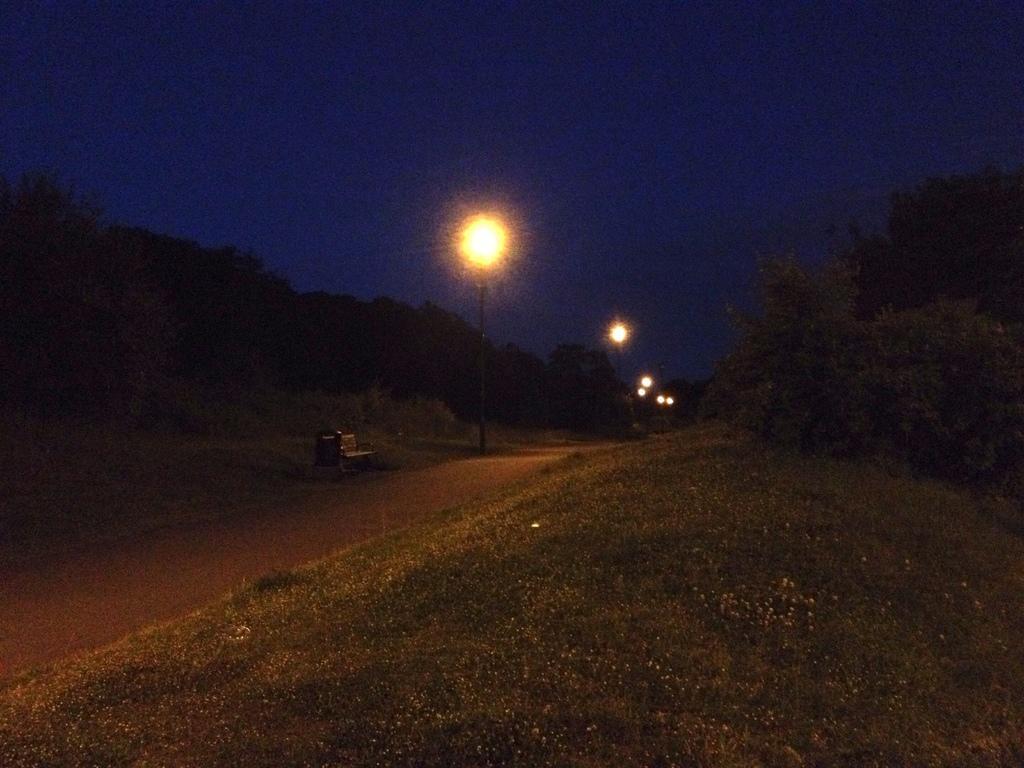In one or two sentences, can you explain what this image depicts? In the picture we can see a dark night and a grass surface near to it, we can see a path and some street lights to the poles and in the background we can see some plants, trees and sky. 